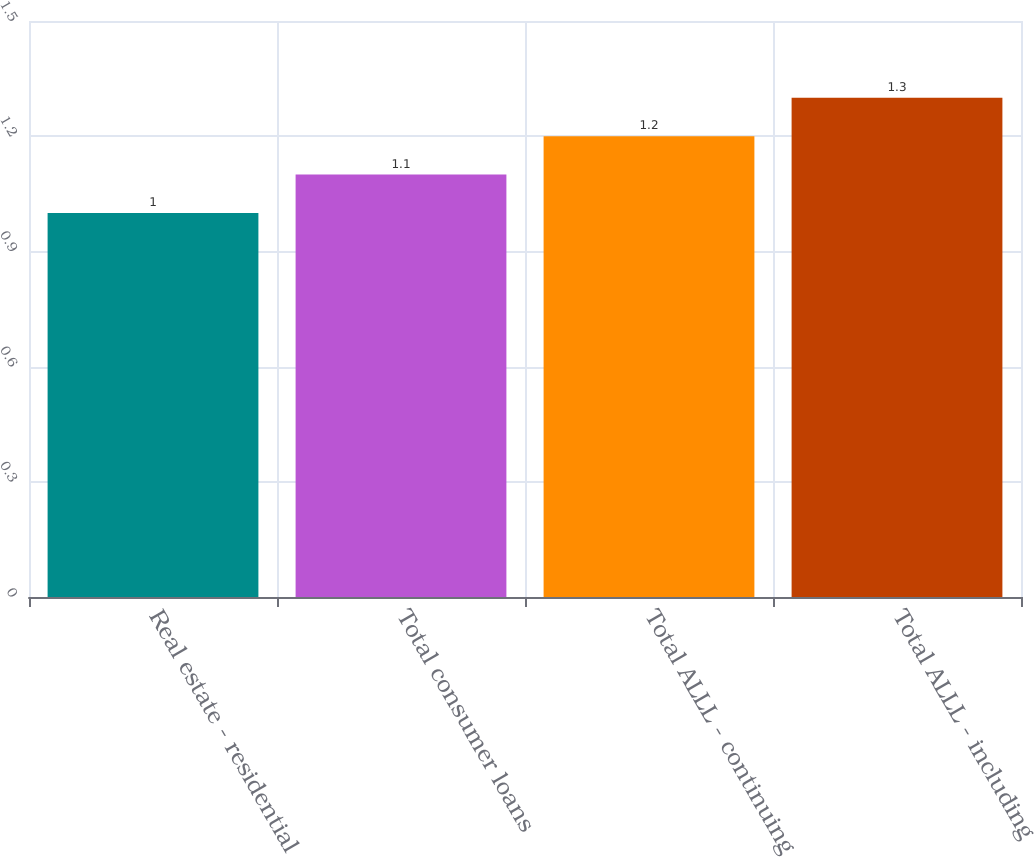Convert chart to OTSL. <chart><loc_0><loc_0><loc_500><loc_500><bar_chart><fcel>Real estate - residential<fcel>Total consumer loans<fcel>Total ALLL - continuing<fcel>Total ALLL - including<nl><fcel>1<fcel>1.1<fcel>1.2<fcel>1.3<nl></chart> 